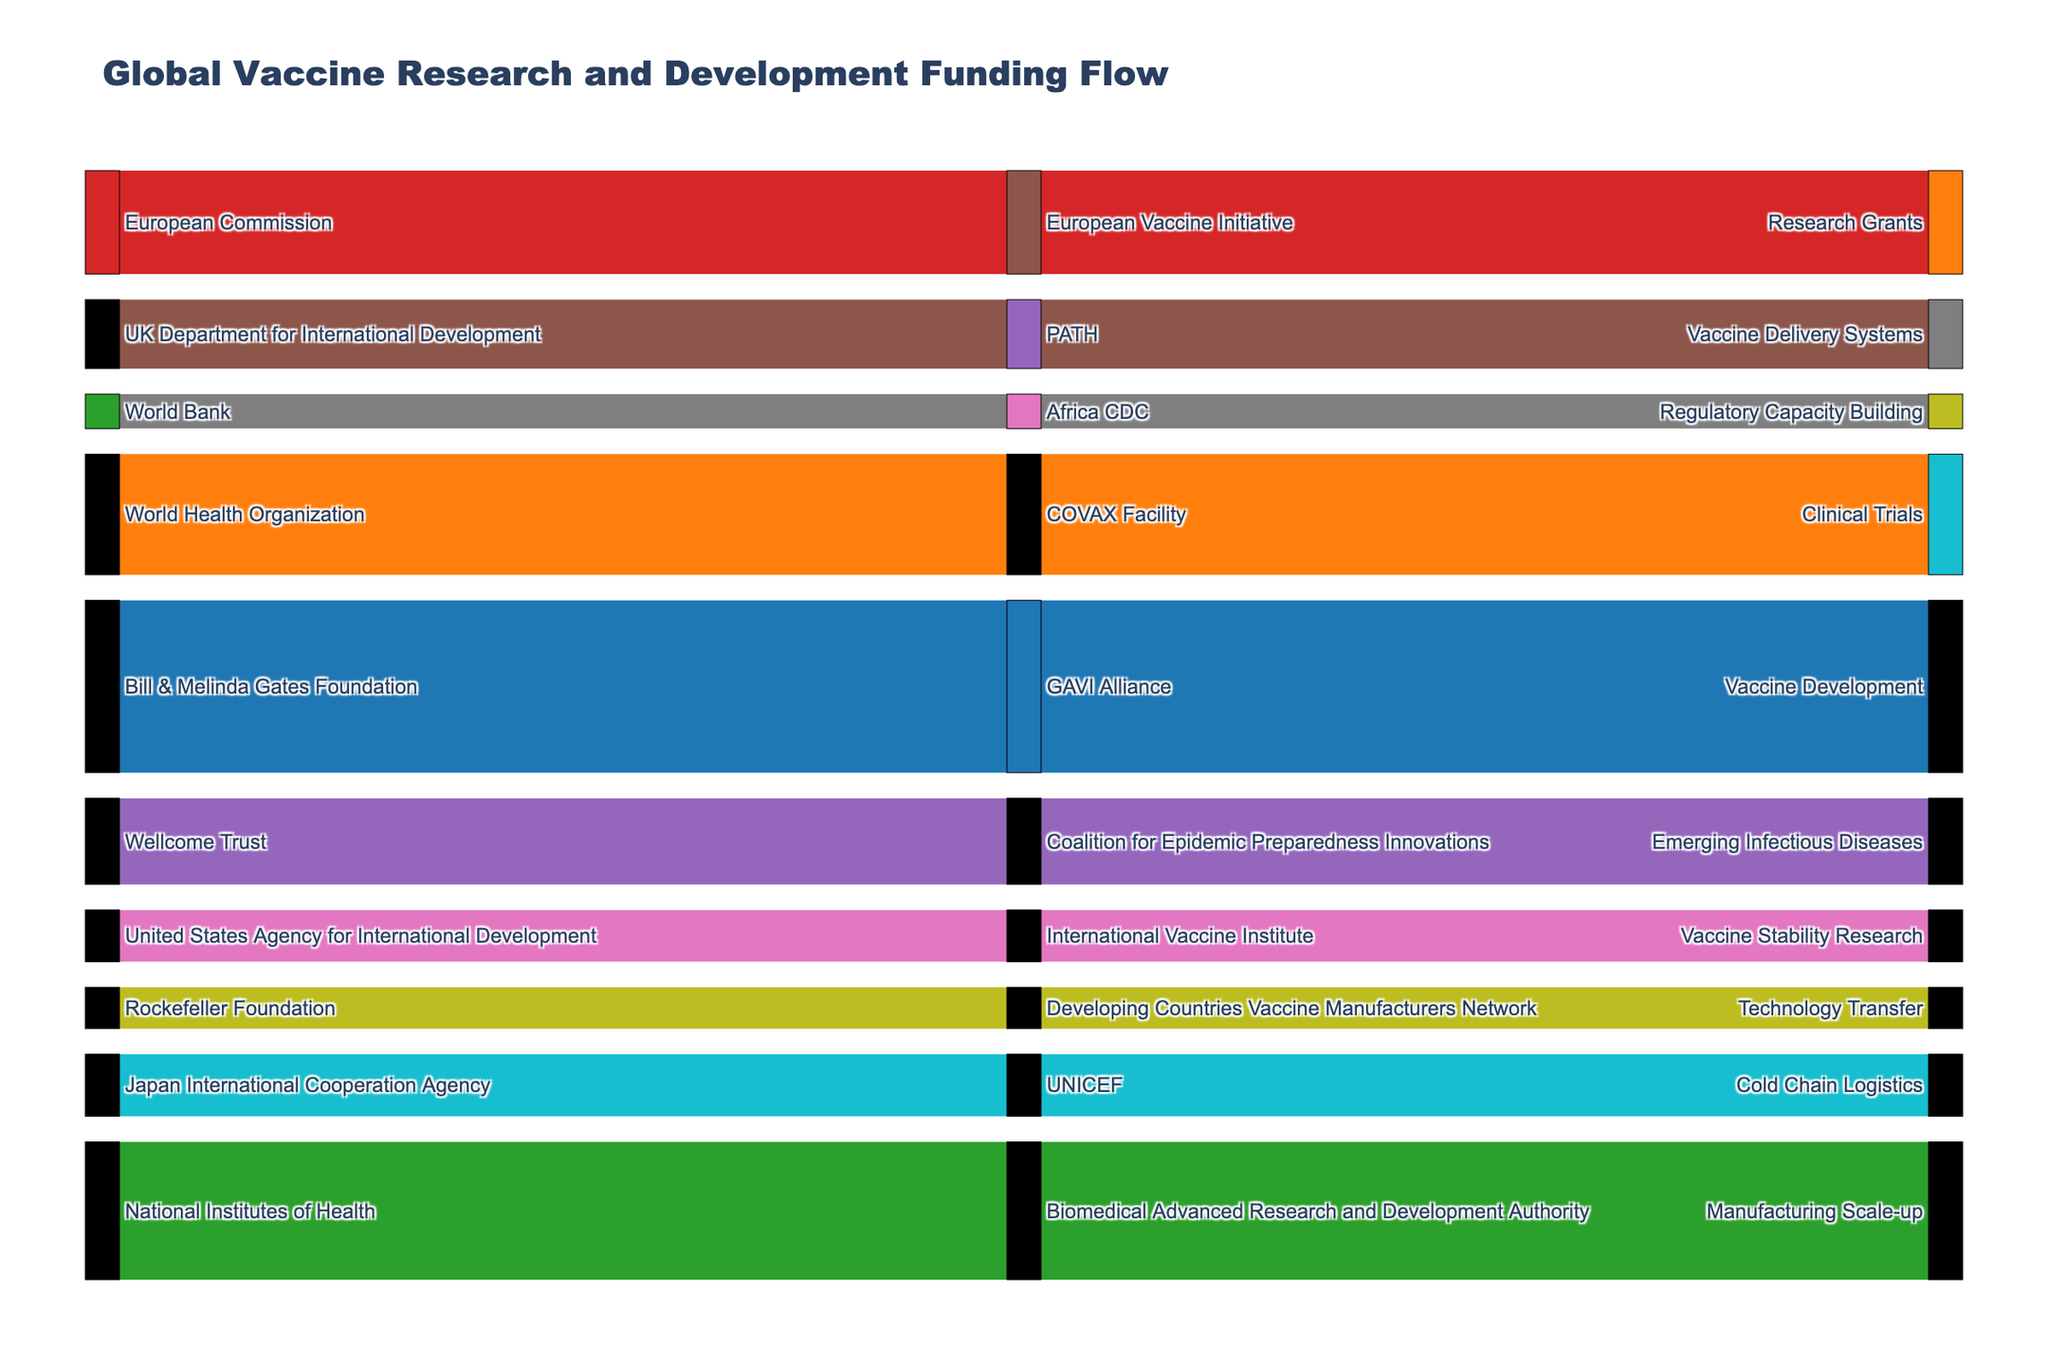What is the title of the figure? The title is located at the top of the figure and provides an overview of what the figure represents.
Answer: Global Vaccine Research and Development Funding Flow How many destination categories are there in the figure? To determine the number of destination categories, count the unique entries in the 'Destination' column of the data.
Answer: 10 Which funding source contributes the most amount of money to vaccine initiatives? Identify the funding source with the largest single contribution from the 'Amount' column.
Answer: Bill & Melinda Gates Foundation What is the total amount contributed by the European Commission and UK Department for International Development combined? Add the amounts contributed by the European Commission (300) and UK Department for International Development (200).
Answer: 500 Which intermediary organization receives funding from the World Health Organization? Identify the intermediary linked to the World Health Organization as the source.
Answer: COVAX Facility Which destination receives the least funding and from which intermediary does it come? Identify the destination with the smallest amount and trace back to the corresponding intermediary.
Answer: Regulatory Capacity Building from Africa CDC Compare the funding amounts between the National Institutes of Health and the Rockefeller Foundation. Who contributes more, and by how much? Compare the amounts provided by the National Institutes of Health (400) and Rockefeller Foundation (120), then compute the difference.
Answer: National Institutes of Health by 280 What is the total funding amount distributed through the COVAX Facility? Trace the funding flowing through the COVAX Facility intermediary and sum the corresponding amounts.
Answer: 350 What proportion of the total funding is contributed by the Bill & Melinda Gates Foundation? Sum all the funding amounts, then divide the contribution of the Bill & Melinda Gates Foundation (500) by this total, and multiply by 100.
Answer: Approximately 20.4% Which destination category receives funding from the Japan International Cooperation Agency? Identify the destination linked to the Japan International Cooperation Agency as the source.
Answer: Cold Chain Logistics 